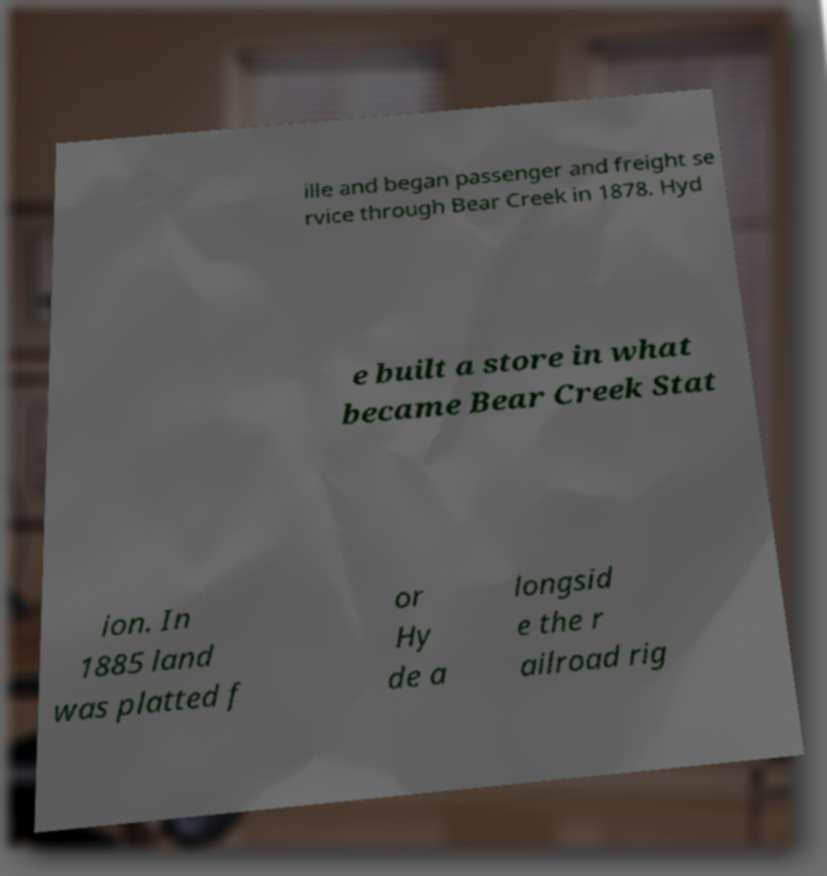Please identify and transcribe the text found in this image. ille and began passenger and freight se rvice through Bear Creek in 1878. Hyd e built a store in what became Bear Creek Stat ion. In 1885 land was platted f or Hy de a longsid e the r ailroad rig 